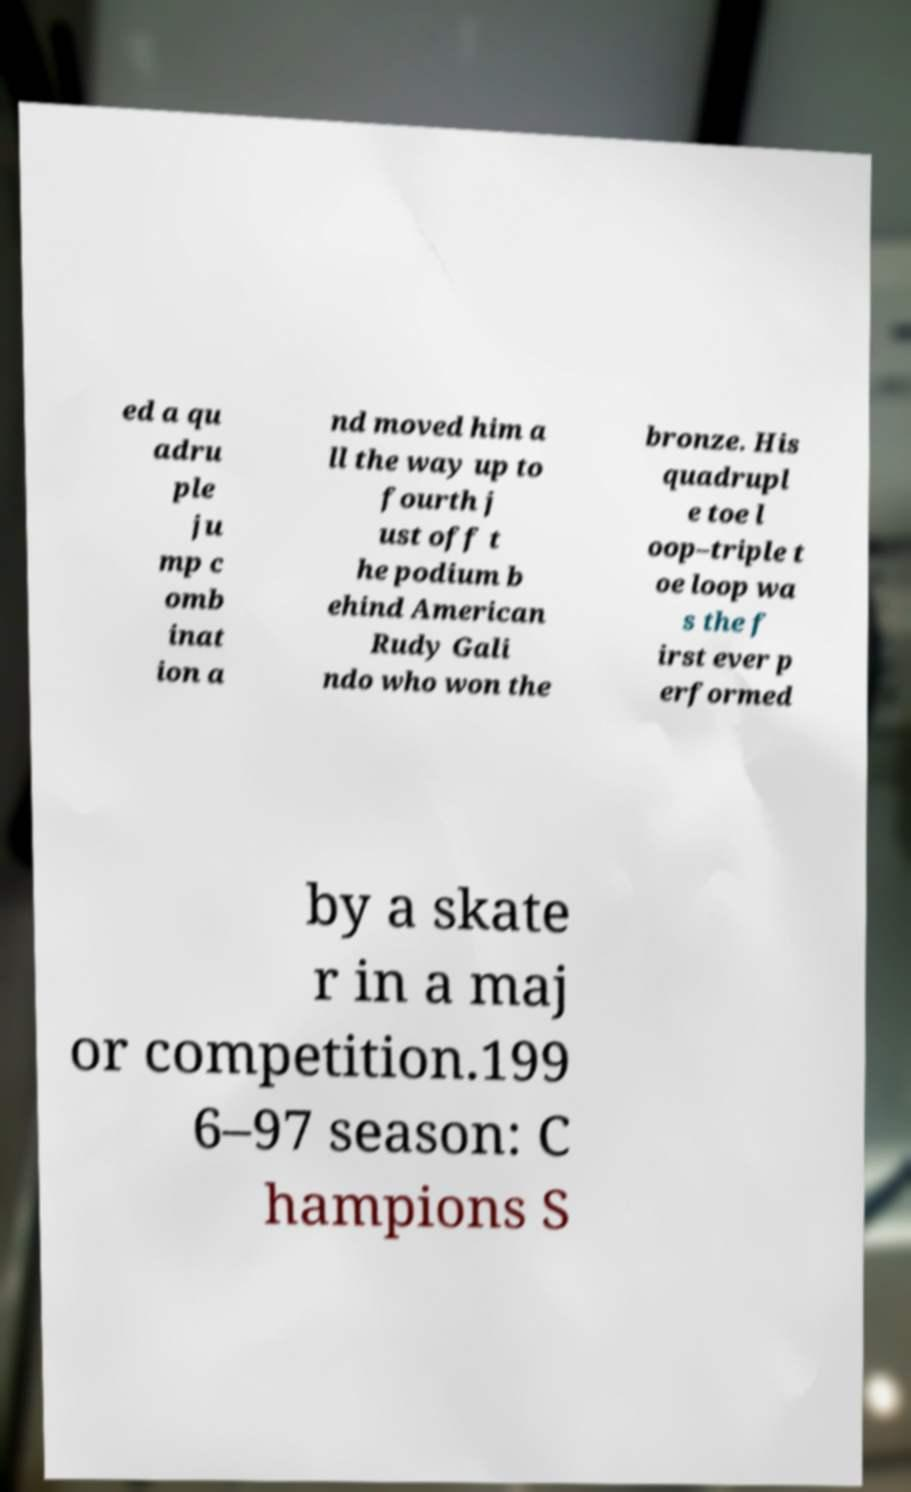I need the written content from this picture converted into text. Can you do that? ed a qu adru ple ju mp c omb inat ion a nd moved him a ll the way up to fourth j ust off t he podium b ehind American Rudy Gali ndo who won the bronze. His quadrupl e toe l oop–triple t oe loop wa s the f irst ever p erformed by a skate r in a maj or competition.199 6–97 season: C hampions S 